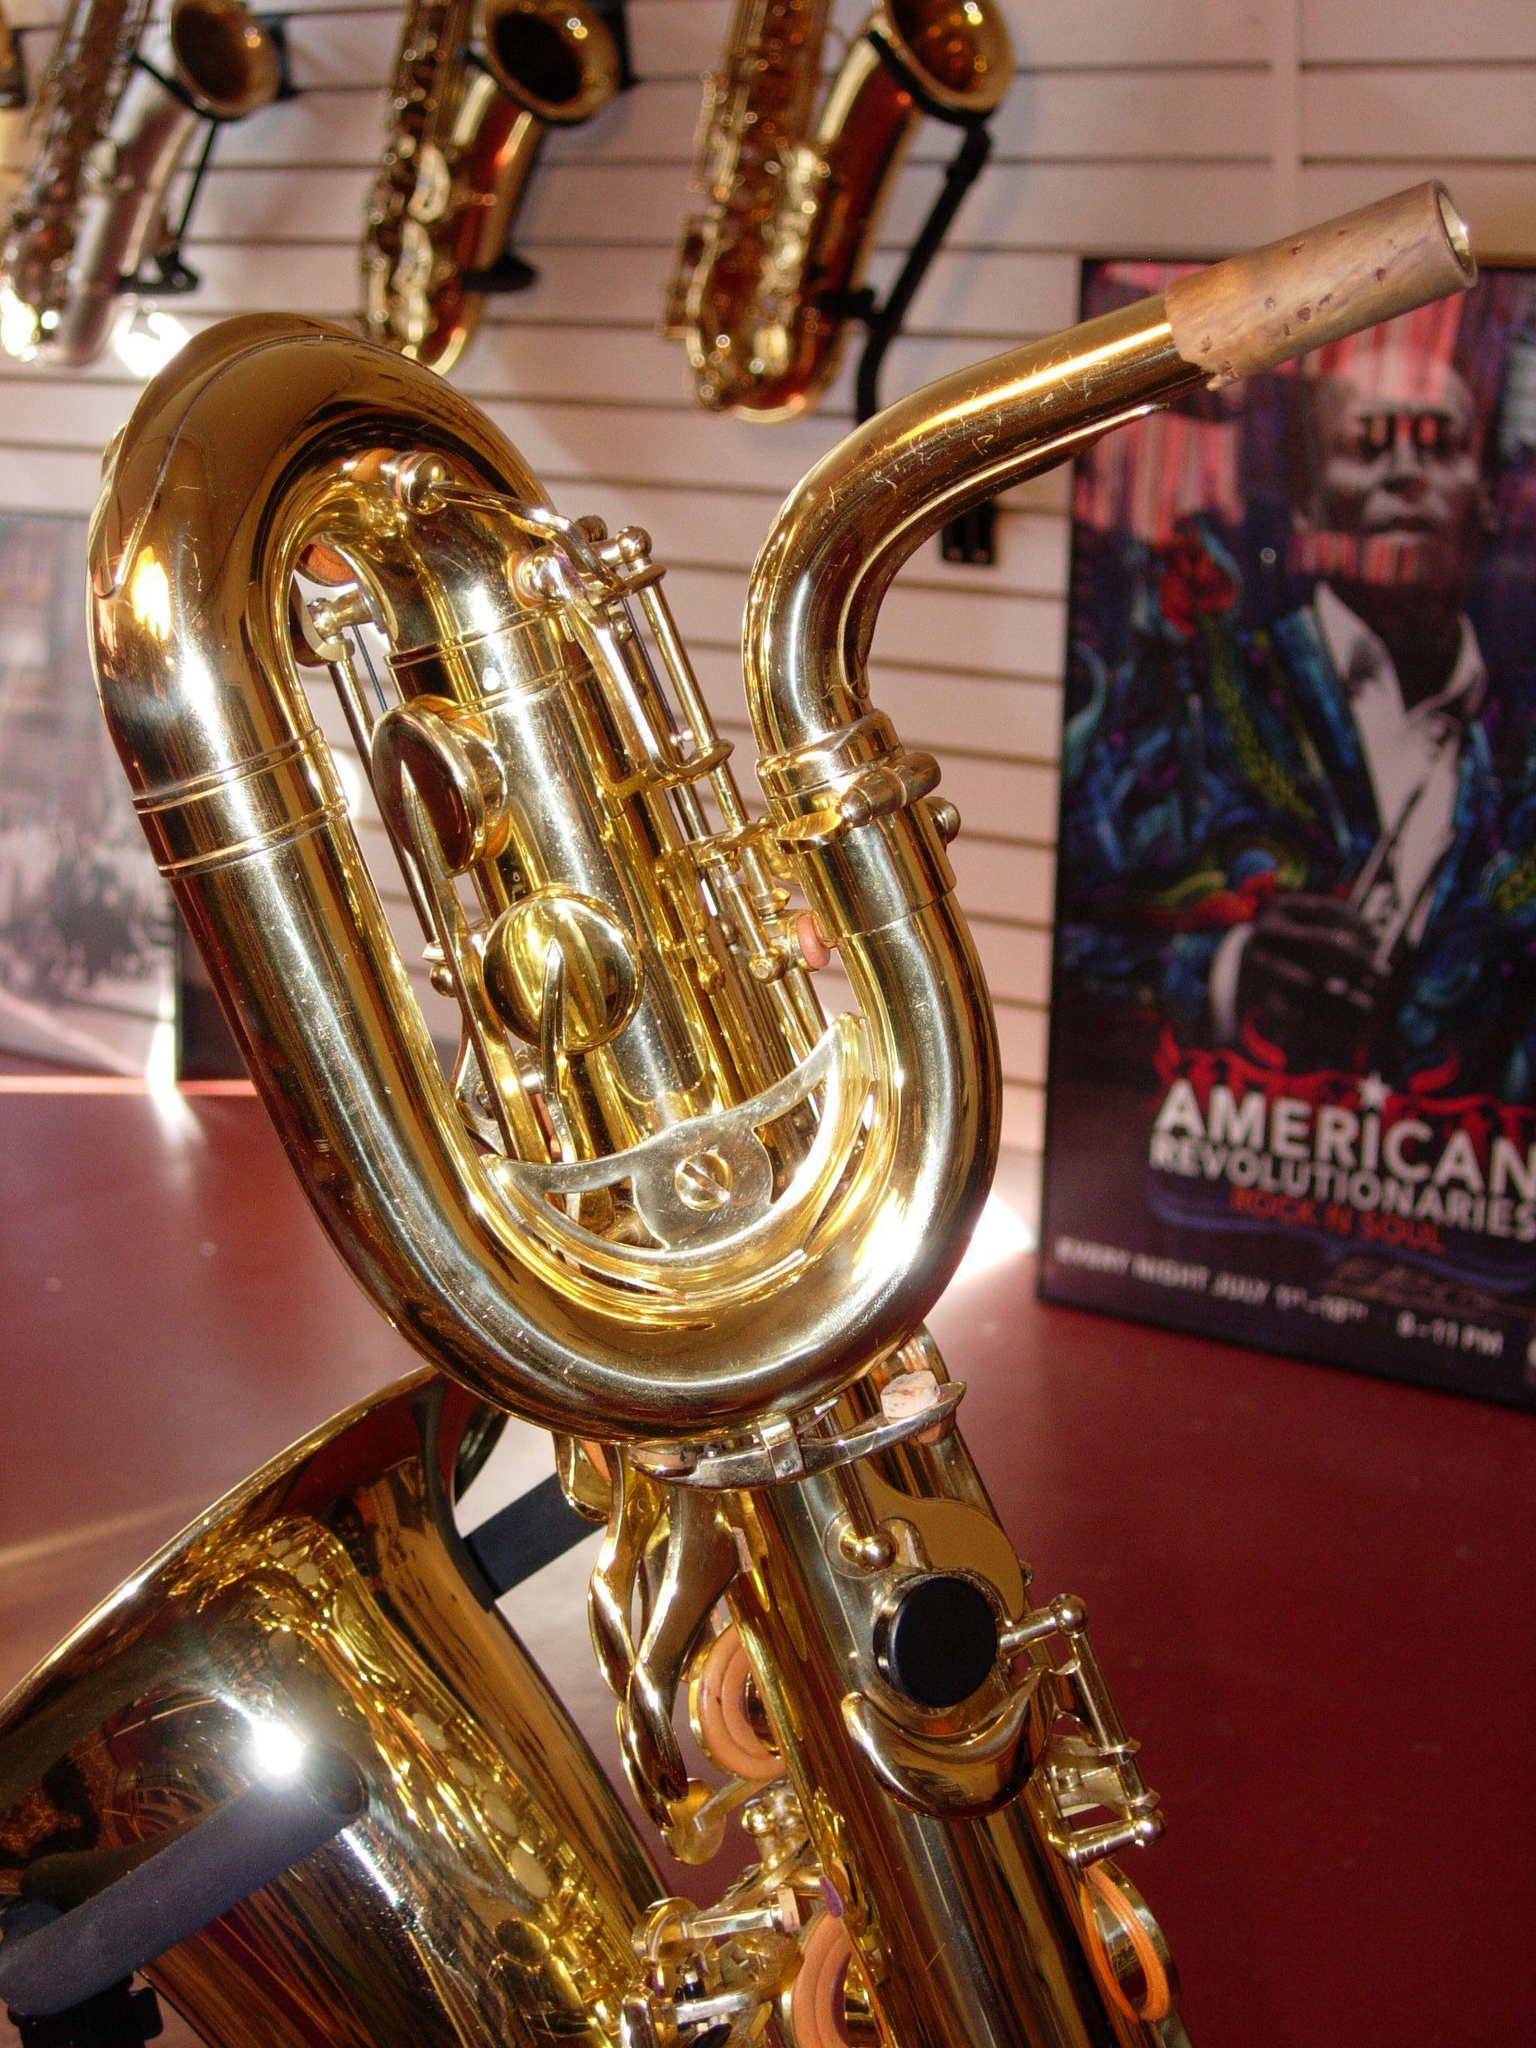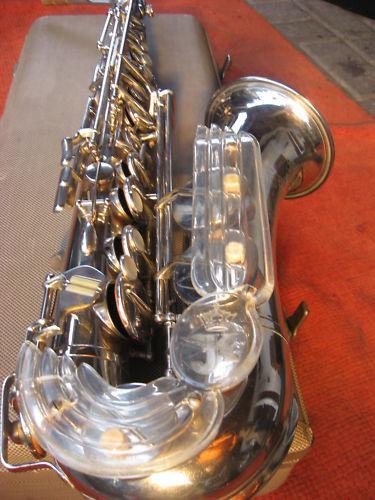The first image is the image on the left, the second image is the image on the right. Examine the images to the left and right. Is the description "One image shows a single rightward facing bell of a saxophone, and the other image shows a gold-colored leftward-facing saxophone in the foreground." accurate? Answer yes or no. Yes. The first image is the image on the left, the second image is the image on the right. Examine the images to the left and right. Is the description "At least one saxophone has engraving on the surface of its body." accurate? Answer yes or no. No. 